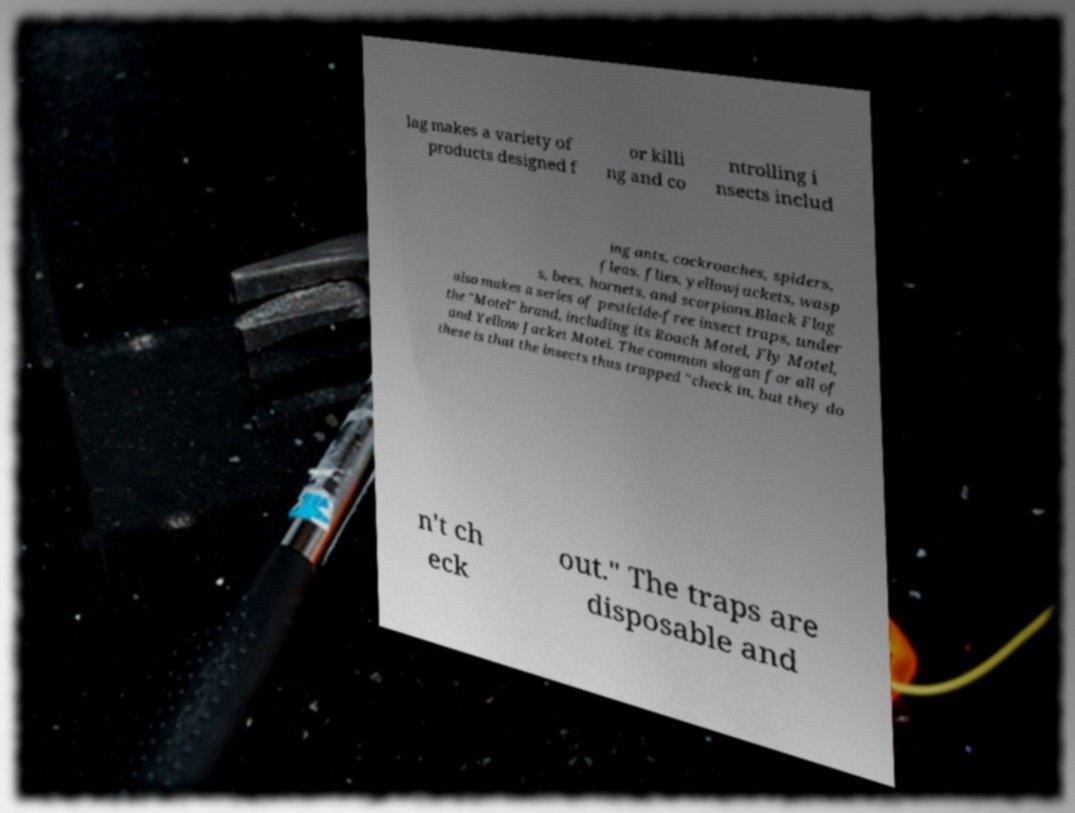There's text embedded in this image that I need extracted. Can you transcribe it verbatim? lag makes a variety of products designed f or killi ng and co ntrolling i nsects includ ing ants, cockroaches, spiders, fleas, flies, yellowjackets, wasp s, bees, hornets, and scorpions.Black Flag also makes a series of pesticide-free insect traps, under the "Motel" brand, including its Roach Motel, Fly Motel, and Yellow Jacket Motel. The common slogan for all of these is that the insects thus trapped "check in, but they do n't ch eck out." The traps are disposable and 